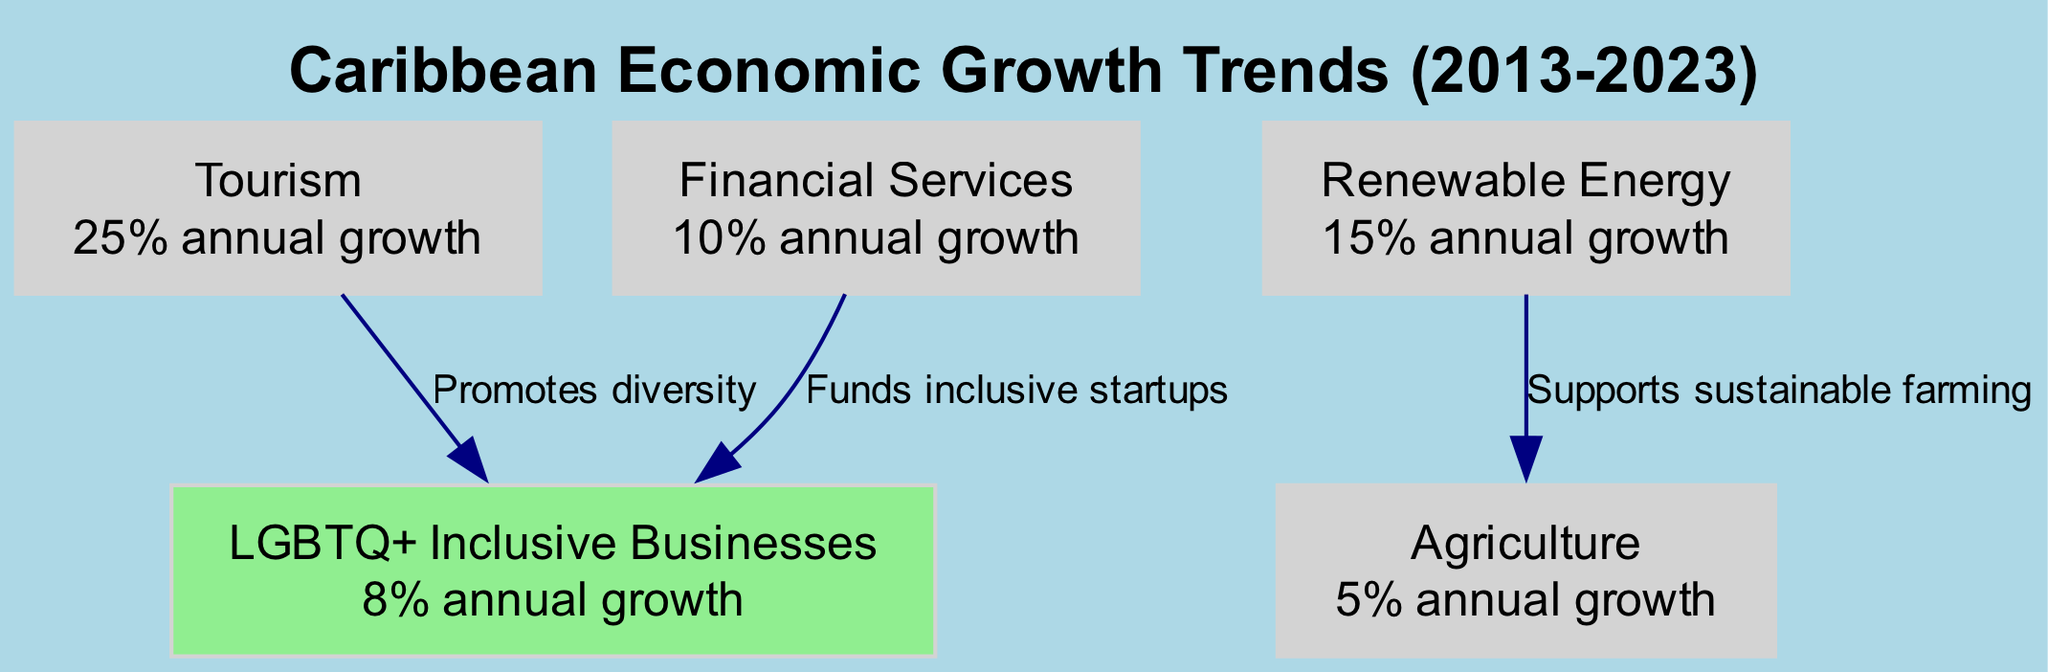What is the annual growth rate of Tourism? The diagram states that Tourism has a growth rate of "25% annual growth", which is mentioned directly in the node's value.
Answer: 25% annual growth Which sector has the lowest annual growth rate? By looking at the values associated with each sector in the nodes, Agriculture has the lowest growth rate of "5% annual growth".
Answer: 5% annual growth How many sectors are represented in the diagram? Counting the nodes listed in the diagram, there are a total of five sectors: Tourism, Renewable Energy, Financial Services, Agriculture, and LGBTQ+ Inclusive Businesses.
Answer: 5 What does the edge between Renewable Energy and Agriculture signify? The edge indicates a relationship, labeled "Supports sustainable farming", which shows how Renewable Energy contributes to Agriculture.
Answer: Supports sustainable farming Which sector funds inclusive startups? The diagram indicates that Financial Services is responsible for funding inclusive startups, as detailed in the edge labeled connecting it to LGBTQ+ Inclusive Businesses.
Answer: Financial Services What relationship does Tourism have with LGBTQ+ Inclusive Businesses? The edge from Tourism to LGBTQ+ Inclusive Businesses is labeled "Promotes diversity", highlighting the associated benefit of this connection.
Answer: Promotes diversity What is the annual growth rate of LGBTQ+ Inclusive Businesses? The node identifies LGBTQ+ Inclusive Businesses as having a growth rate of "8% annual growth".
Answer: 8% annual growth Which sector has a higher growth rate, Financial Services or Agriculture? Financial Services has an annual growth rate of "10% annual growth", while Agriculture has "5% annual growth", making Financial Services the higher of the two.
Answer: Financial Services What is the total number of edges in the diagram? By counting the edges shown in the diagram, there are three connections illustrated between the sectors.
Answer: 3 